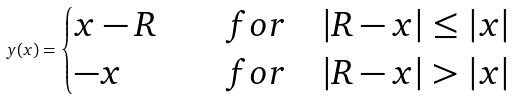<formula> <loc_0><loc_0><loc_500><loc_500>y ( x ) = \begin{cases} x - R & \quad f o r \quad | R - x | \leq | x | \\ - x & \quad f o r \quad | R - x | > | x | \end{cases}</formula> 